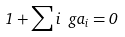Convert formula to latex. <formula><loc_0><loc_0><loc_500><loc_500>1 + \sum i \ g a _ { i } = 0</formula> 